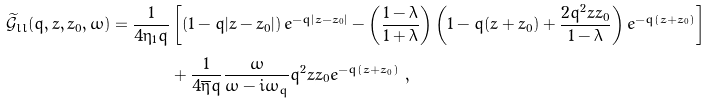<formula> <loc_0><loc_0><loc_500><loc_500>\widetilde { \mathcal { G } } _ { l l } ( q , z , z _ { 0 } , \omega ) = \frac { 1 } { 4 \eta _ { 1 } q } & \left [ \left ( 1 - q | z - z _ { 0 } | \right ) e ^ { - q | z - z _ { 0 } | } - \left ( \frac { 1 - \lambda } { 1 + \lambda } \right ) \left ( 1 - q ( z + z _ { 0 } ) + \frac { 2 q ^ { 2 } z z _ { 0 } } { 1 - \lambda } \right ) e ^ { - q ( z + z _ { 0 } ) } \right ] \\ & + \frac { 1 } { 4 \overline { \eta } q } \frac { \omega } { \omega - i \omega _ { q } } q ^ { 2 } z z _ { 0 } e ^ { - q ( z + z _ { 0 } ) } \ ,</formula> 